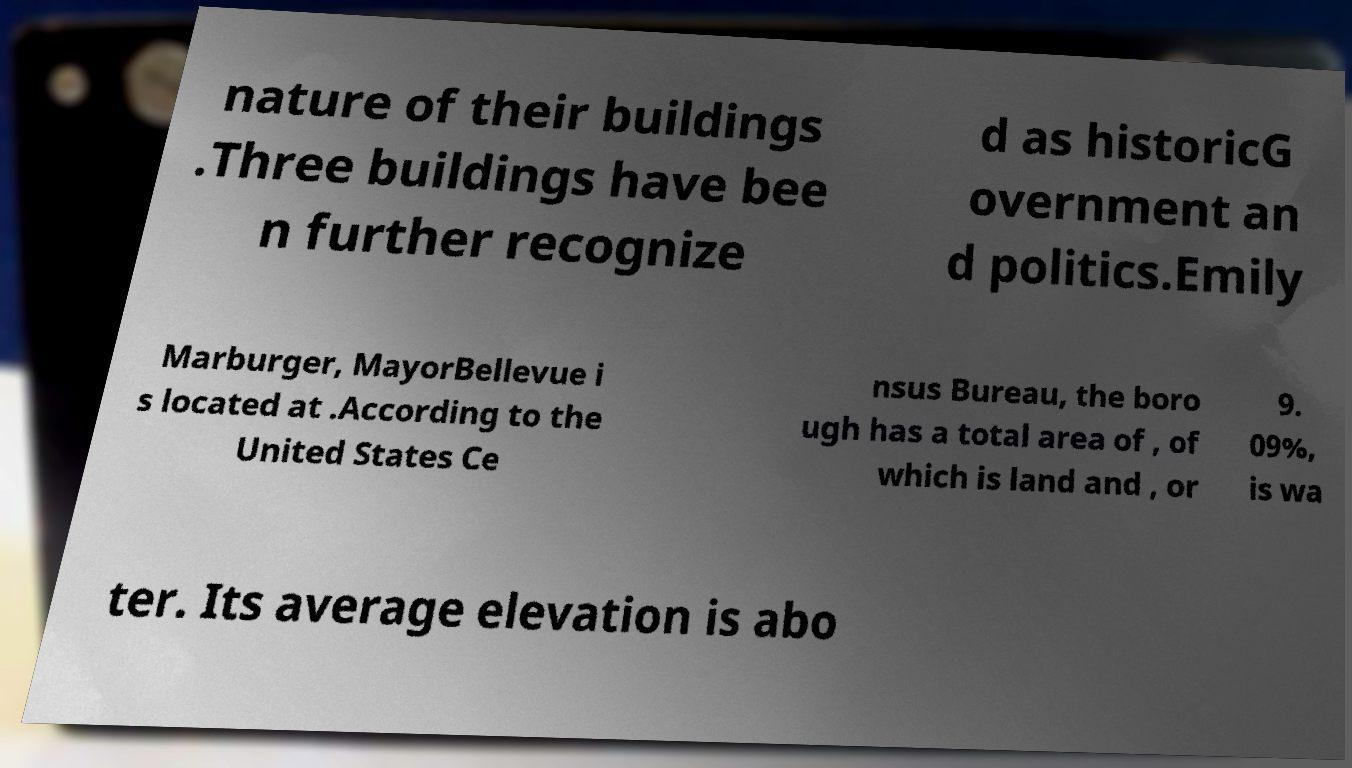There's text embedded in this image that I need extracted. Can you transcribe it verbatim? nature of their buildings .Three buildings have bee n further recognize d as historicG overnment an d politics.Emily Marburger, MayorBellevue i s located at .According to the United States Ce nsus Bureau, the boro ugh has a total area of , of which is land and , or 9. 09%, is wa ter. Its average elevation is abo 